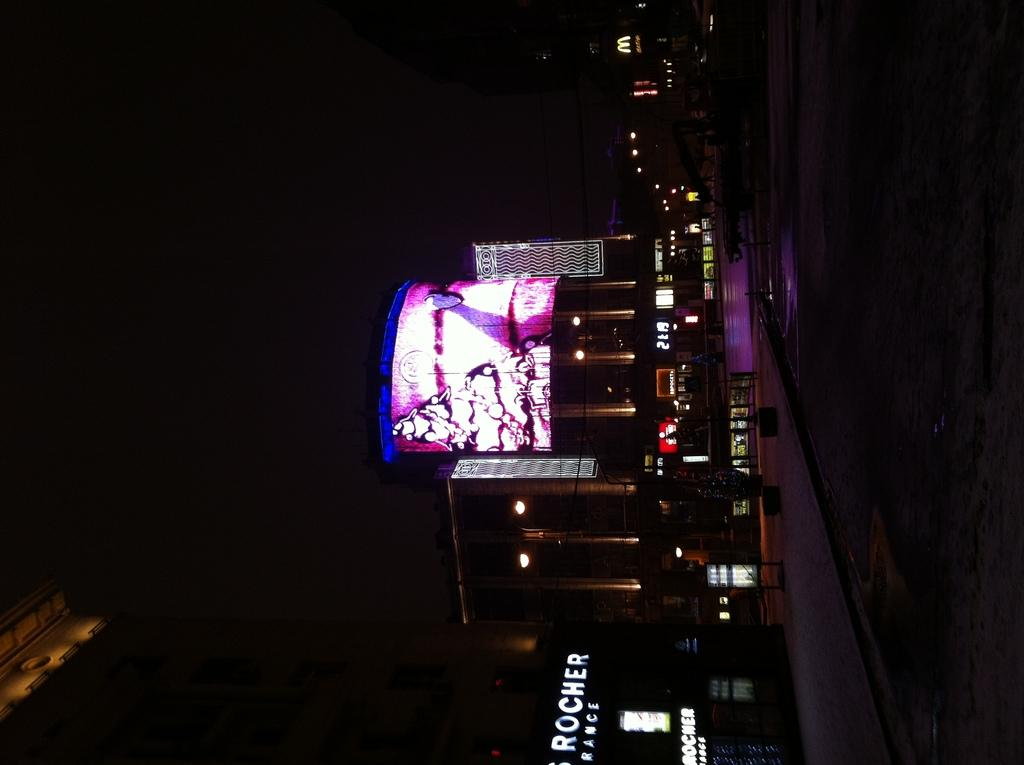What type of structure is present in the image? There is a building in the image. What can be seen on the building in the image? There is a screen visible on the building. What type of accessory is visible in the image? An electronic watch is visible in the image. What type of illumination is present in the image? There are lights in the image. What type of establishment is present in the image? There is a store in the image. What type of transportation infrastructure is present in the image? There is a road in the image. What type of stamp can be seen on the electronic watch in the image? There is no stamp present on the electronic watch in the image. What type of rhythm is being played by the store in the image? There is no indication of music or rhythm in the image, as it features a building, screen, electronic watch, lights, store, and road. 